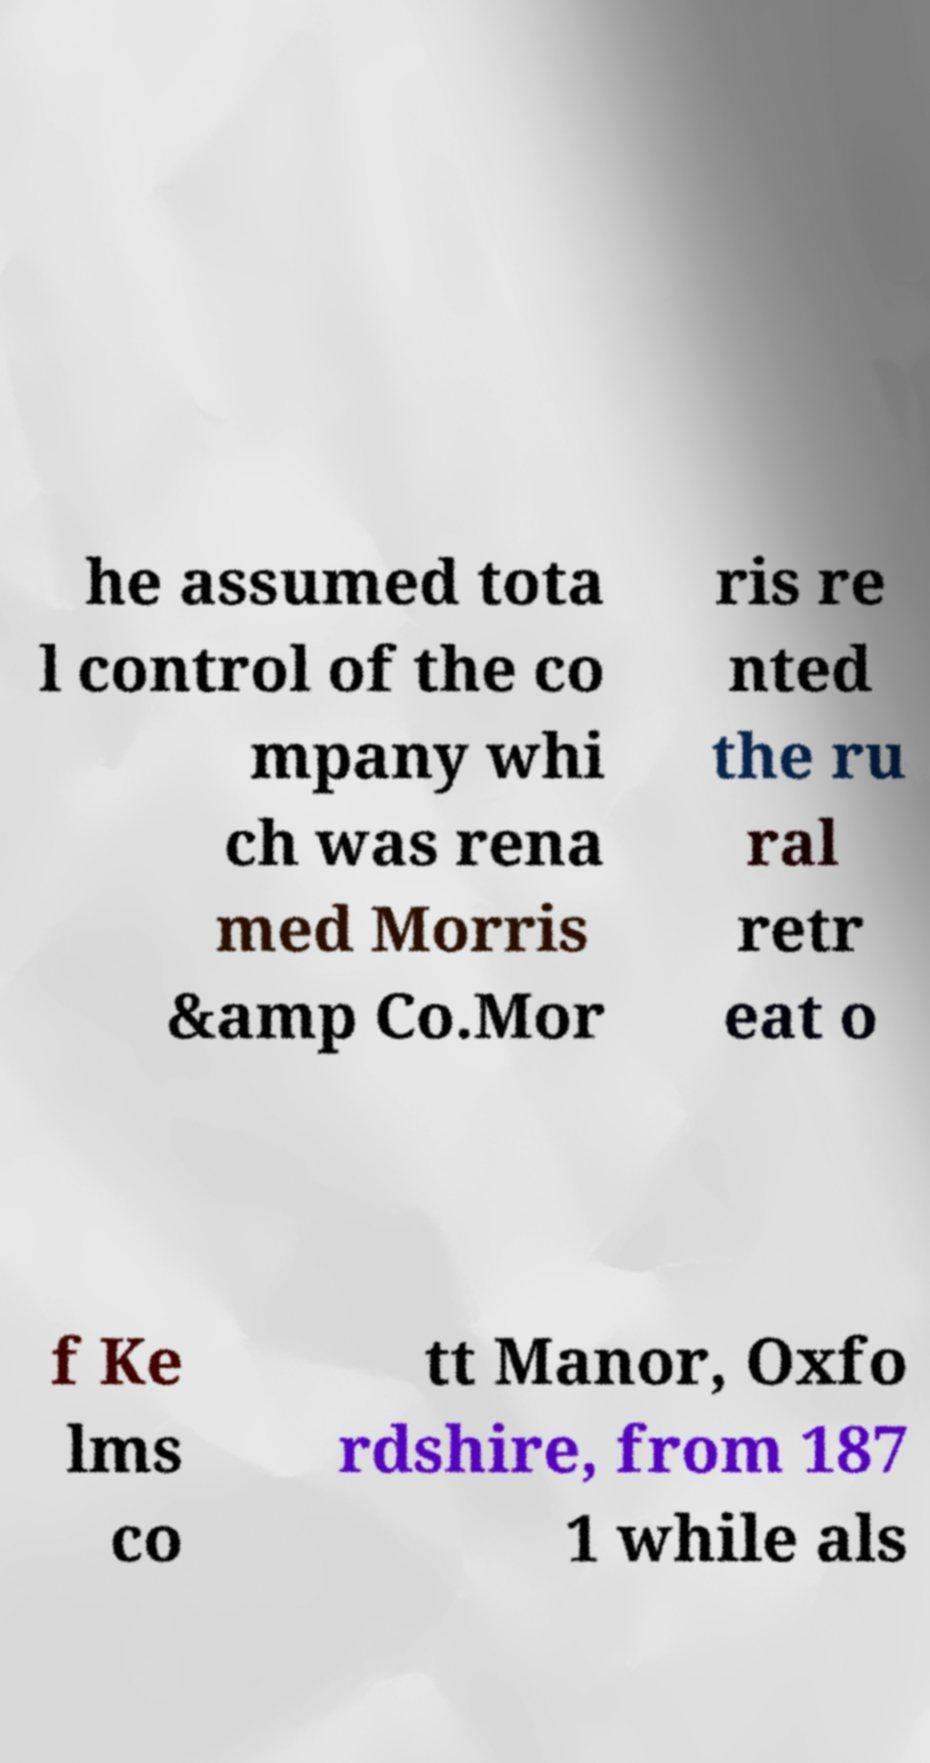Please identify and transcribe the text found in this image. he assumed tota l control of the co mpany whi ch was rena med Morris &amp Co.Mor ris re nted the ru ral retr eat o f Ke lms co tt Manor, Oxfo rdshire, from 187 1 while als 